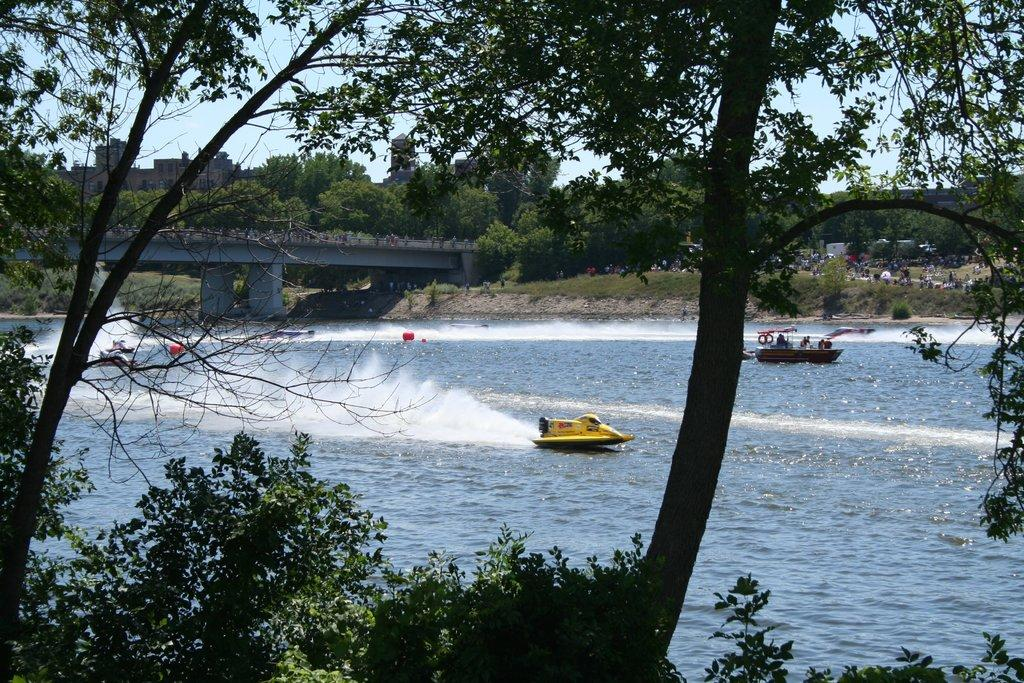What are the people in the image doing? The people in the image are riding boats. Where are the boats located? The boats are on the water surface. What can be seen in the background of the image? There are trees and plants visible in the image. What architectural feature is present in the image? There is a bridge in the image. What type of vegetation is present on the ground? There is grass in the image. What type of silverware is being used to compare the boats in the image? There is no silverware or comparison activity present in the image. Can you see any bubbles in the water around the boats? There is no mention of bubbles in the water in the image. 